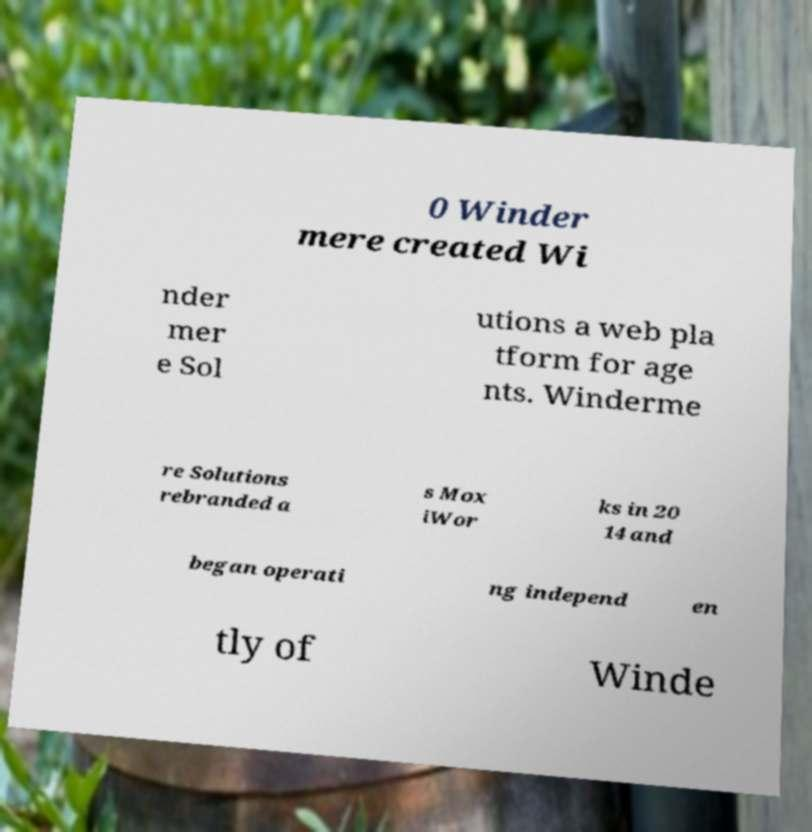Could you assist in decoding the text presented in this image and type it out clearly? 0 Winder mere created Wi nder mer e Sol utions a web pla tform for age nts. Winderme re Solutions rebranded a s Mox iWor ks in 20 14 and began operati ng independ en tly of Winde 